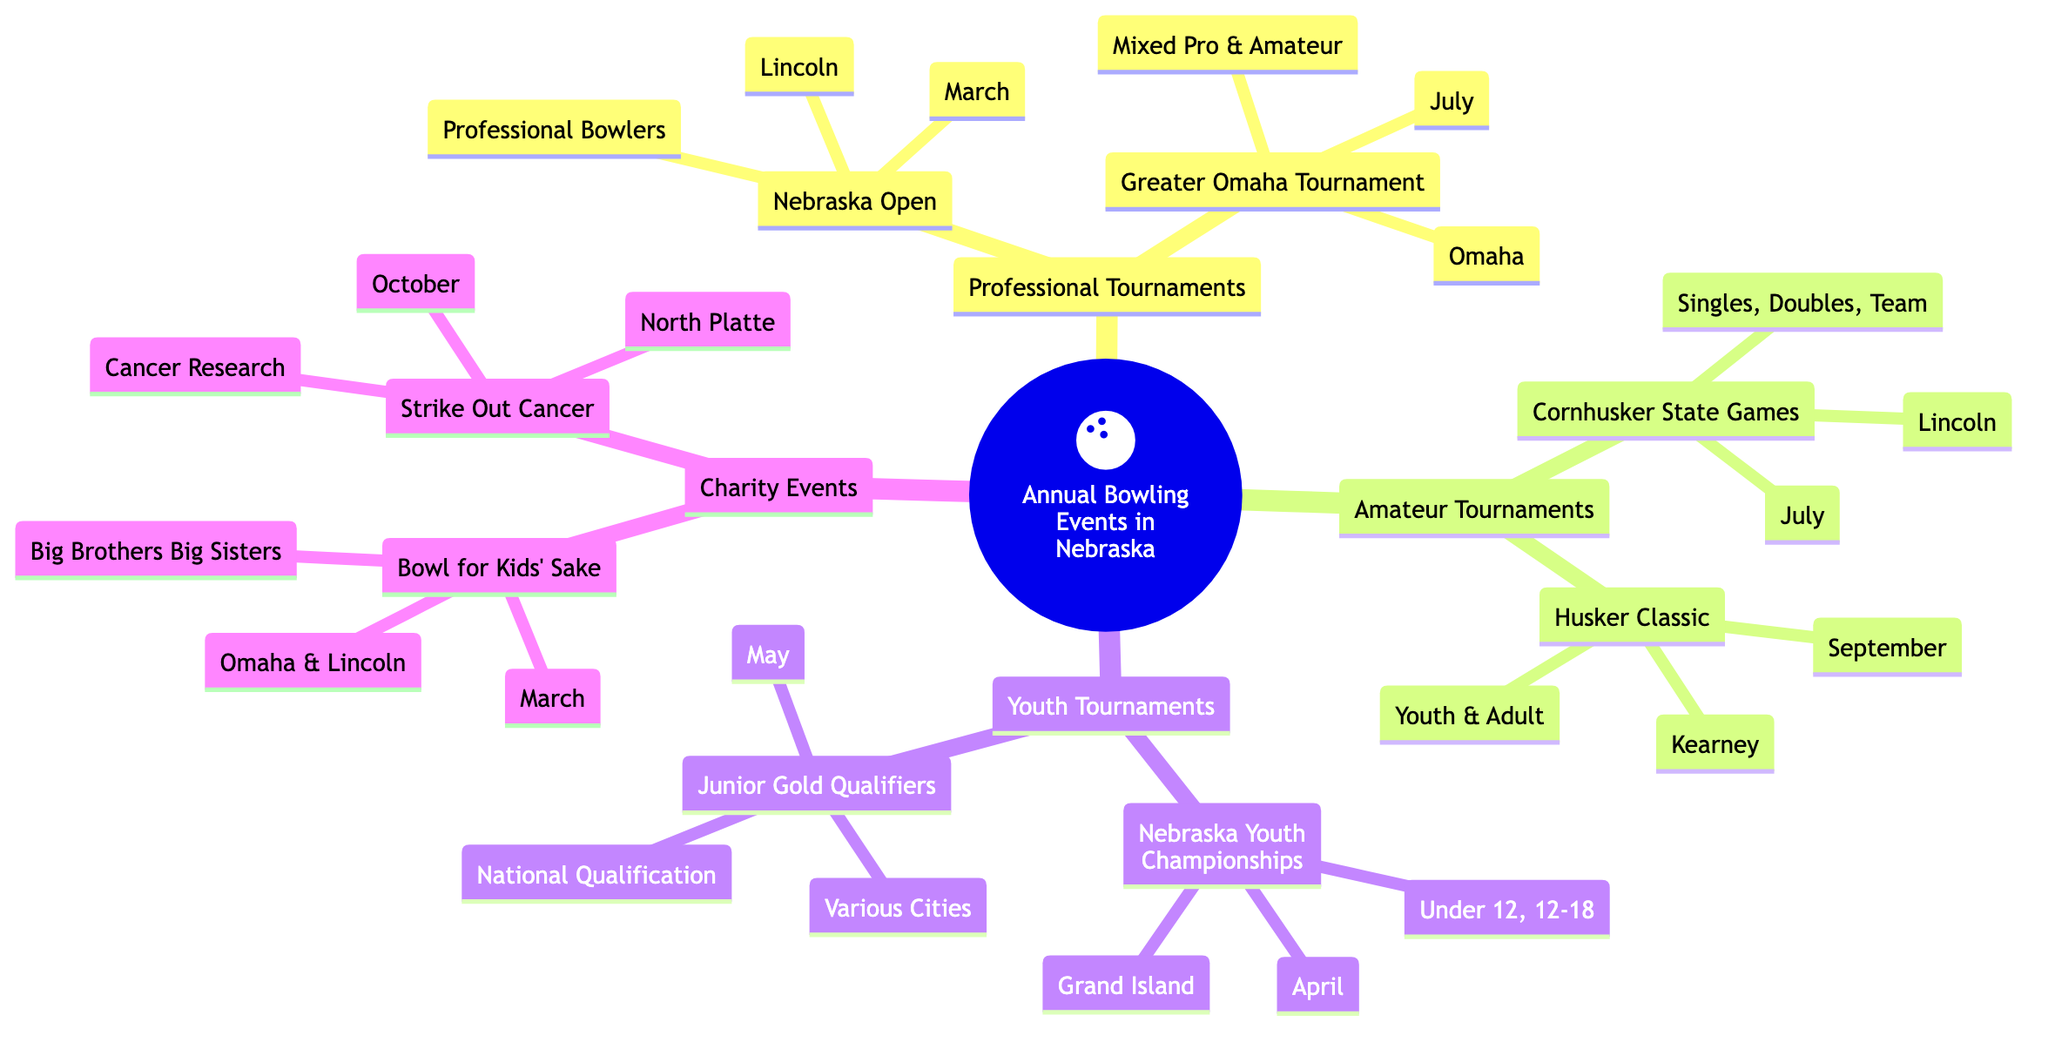What are the two locations for the "Bowl for Kids' Sake" event? The diagram specifies that the "Bowl for Kids' Sake" event takes place in both Omaha and Lincoln under the Charity Events category.
Answer: Omaha, Lincoln How many professional tournaments are listed? The diagram shows two professional tournaments: "Nebraska Open" and "Greater Omaha Tournament." Thus, the count is two.
Answer: 2 In which month is the "Husker Classic" held? The diagram indicates that the "Husker Classic" tournament is scheduled for September under the Amateur Tournaments category.
Answer: September What is the date for the "Nebraska Youth Championships"? According to the diagram, the "Nebraska Youth Championships" takes place in April listed under the Youth Tournaments section.
Answer: April Which charity event takes place in October? The diagram reveals that the "Strike Out Cancer" charity event occurs in October, as outlined in the Charity Events section.
Answer: Strike Out Cancer What categories are available in the "Cornhusker State Games"? The diagram shows that the "Cornhusker State Games" features three categories: Singles, Doubles, and Team in the Amateur Tournaments section.
Answer: Singles, Doubles, Team What type of participants are in the "Greater Omaha Tournament"? The diagram specifies that the "Greater Omaha Tournament" is for mixed professional and amateur participants as indicated in the Professional Tournaments category.
Answer: Mixed Professional and Amateur Which tournament has youth divisions specifically under 12? The diagram states that the "Nebraska Youth Championships" includes a division for under 12 in the Youth Tournaments section.
Answer: Nebraska Youth Championships 